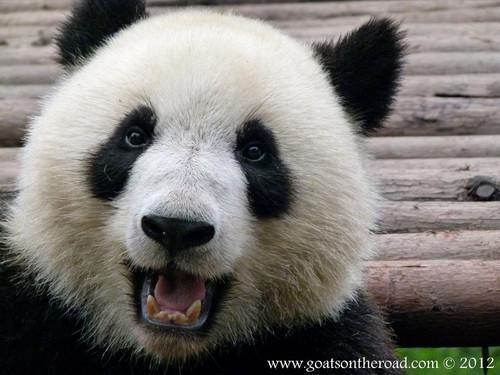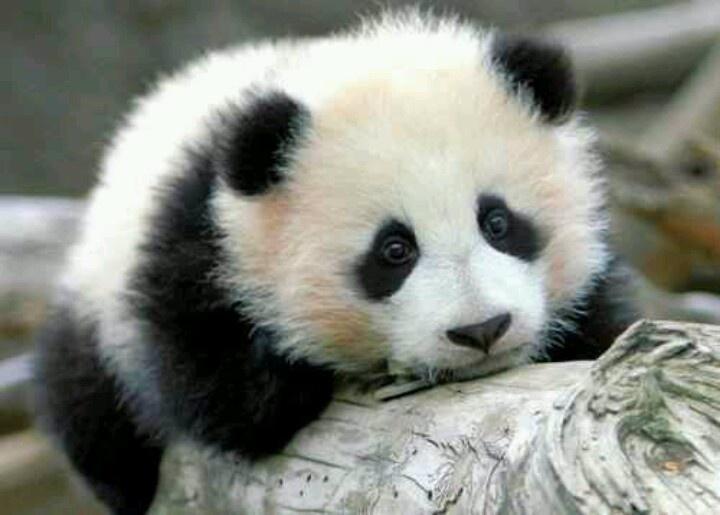The first image is the image on the left, the second image is the image on the right. Analyze the images presented: Is the assertion "A panda is hanging on a branch" valid? Answer yes or no. No. 